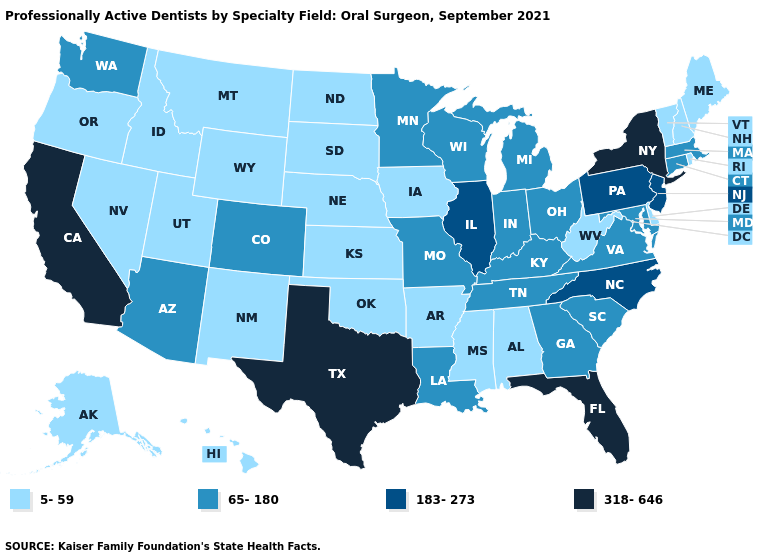Which states have the lowest value in the MidWest?
Concise answer only. Iowa, Kansas, Nebraska, North Dakota, South Dakota. What is the value of Nevada?
Write a very short answer. 5-59. Does Utah have the same value as Minnesota?
Quick response, please. No. Does Nebraska have the same value as South Dakota?
Quick response, please. Yes. Which states have the lowest value in the MidWest?
Short answer required. Iowa, Kansas, Nebraska, North Dakota, South Dakota. Name the states that have a value in the range 65-180?
Short answer required. Arizona, Colorado, Connecticut, Georgia, Indiana, Kentucky, Louisiana, Maryland, Massachusetts, Michigan, Minnesota, Missouri, Ohio, South Carolina, Tennessee, Virginia, Washington, Wisconsin. Name the states that have a value in the range 318-646?
Quick response, please. California, Florida, New York, Texas. Name the states that have a value in the range 5-59?
Answer briefly. Alabama, Alaska, Arkansas, Delaware, Hawaii, Idaho, Iowa, Kansas, Maine, Mississippi, Montana, Nebraska, Nevada, New Hampshire, New Mexico, North Dakota, Oklahoma, Oregon, Rhode Island, South Dakota, Utah, Vermont, West Virginia, Wyoming. Does Michigan have the highest value in the USA?
Short answer required. No. Among the states that border Alabama , which have the lowest value?
Write a very short answer. Mississippi. Among the states that border New Hampshire , does Maine have the highest value?
Short answer required. No. What is the value of West Virginia?
Be succinct. 5-59. What is the value of Mississippi?
Answer briefly. 5-59. What is the value of Wyoming?
Concise answer only. 5-59. What is the highest value in the USA?
Give a very brief answer. 318-646. 